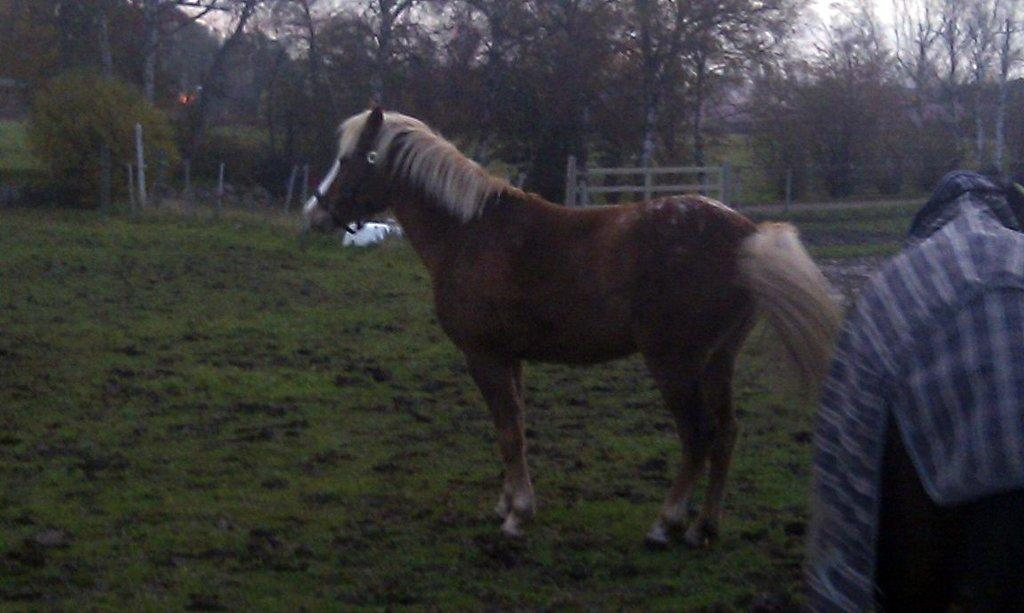What animal is on the ground in the image? There is a horse on the ground in the image. What type of clothing is visible on the right side of the image? There is a shirt on the right side of the image. What can be seen in the background of the image? There is a fence and trees in the background of the image. How many boys are involved in the discovery of the new body in the image? There is no mention of a body or boys in the image; it features a horse, a shirt, a fence, and trees. 